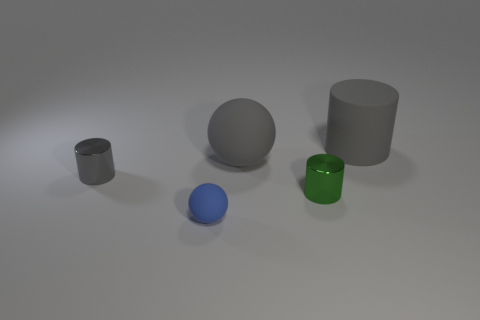Subtract all tiny metal cylinders. How many cylinders are left? 1 Subtract all green cylinders. How many cylinders are left? 2 Add 2 big green metallic blocks. How many objects exist? 7 Subtract all cylinders. How many objects are left? 2 Subtract all spheres. Subtract all big matte cylinders. How many objects are left? 2 Add 4 small gray objects. How many small gray objects are left? 5 Add 3 blue spheres. How many blue spheres exist? 4 Subtract 0 cyan cubes. How many objects are left? 5 Subtract 1 balls. How many balls are left? 1 Subtract all red cylinders. Subtract all brown balls. How many cylinders are left? 3 